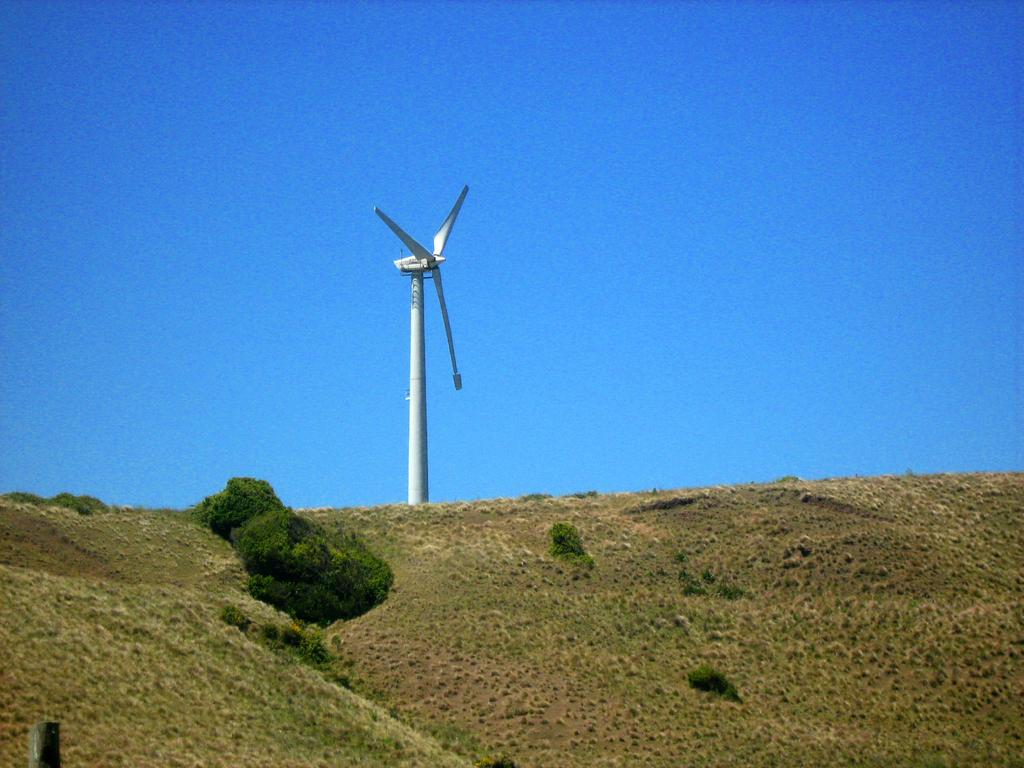What is the main structure in the image? There is a windmill in the image. What can be seen at the bottom of the image? There are plants and a pole at the bottom of the image. What is visible in the background of the image? The sky is visible in the background of the image. What type of soup is being served to the boys at the camp in the image? There is no camp, boys, or soup present in the image. The image features a windmill, plants, a pole, and the sky. 